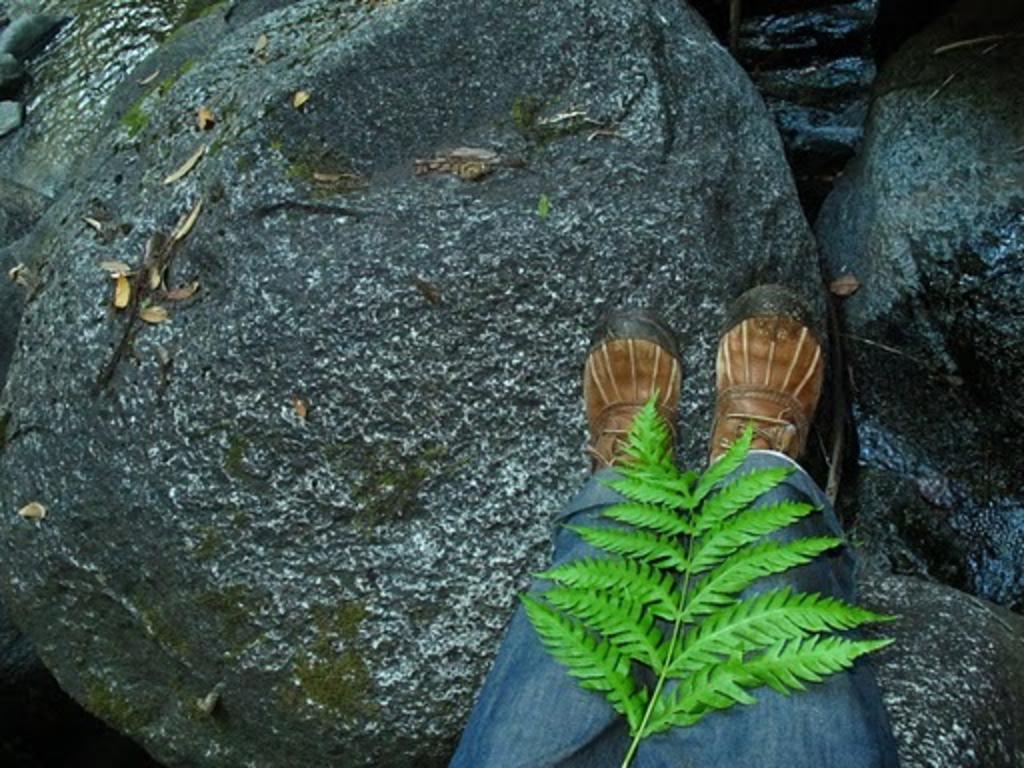Please provide a concise description of this image. In this image we can see two legs of a person in which we can see leaves on a stem. in the background, we can see a group of rocks. 